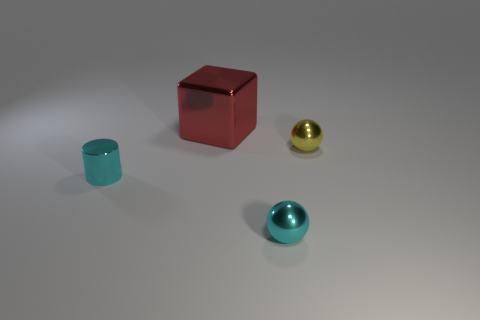What number of big things are either shiny cylinders or gray blocks?
Make the answer very short. 0. There is a small cyan thing that is left of the big cube; what is its shape?
Your response must be concise. Cylinder. Is there a shiny sphere of the same color as the big thing?
Provide a short and direct response. No. There is a cyan shiny object on the right side of the block; is its size the same as the thing that is left of the big red thing?
Provide a short and direct response. Yes. Are there more small metal spheres that are on the left side of the yellow metallic ball than big red shiny blocks on the right side of the cube?
Your answer should be compact. Yes. Are there any large cubes that have the same material as the tiny yellow thing?
Your answer should be compact. Yes. Do the big metallic cube and the shiny cylinder have the same color?
Your answer should be compact. No. What is the color of the large metallic block?
Keep it short and to the point. Red. How many small cyan metallic objects are the same shape as the large red thing?
Your answer should be very brief. 0. There is a thing that is in front of the cyan object that is to the left of the large metallic thing; what size is it?
Your response must be concise. Small. 